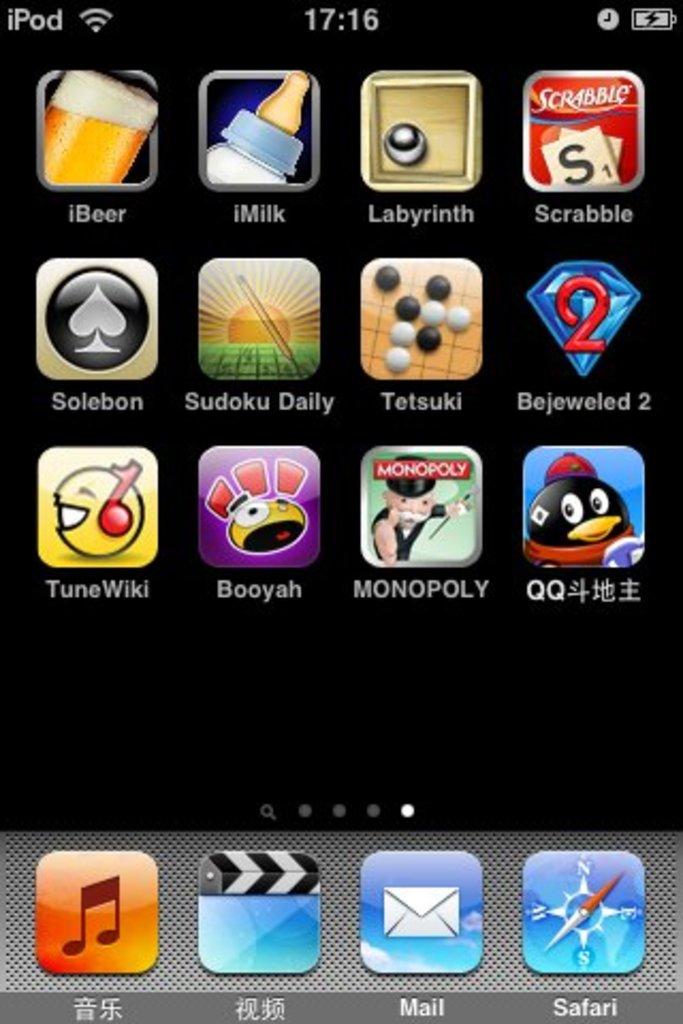What is the name of the app with headphones and an emojii?
Give a very brief answer. Tunewiki. What is the name of the app on the top right?
Your response must be concise. Scrabble. 